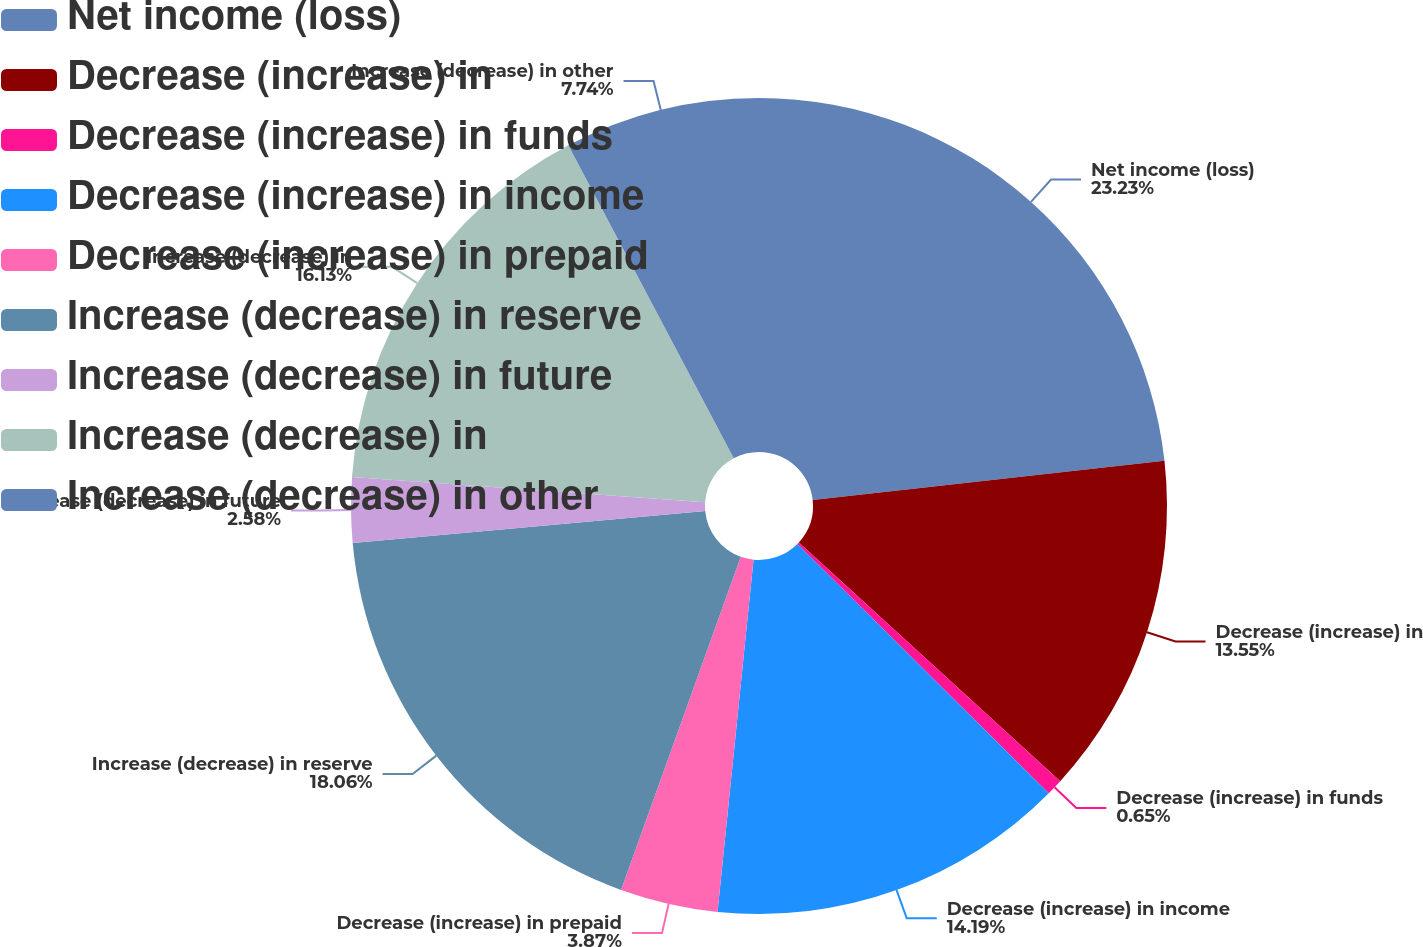<chart> <loc_0><loc_0><loc_500><loc_500><pie_chart><fcel>Net income (loss)<fcel>Decrease (increase) in<fcel>Decrease (increase) in funds<fcel>Decrease (increase) in income<fcel>Decrease (increase) in prepaid<fcel>Increase (decrease) in reserve<fcel>Increase (decrease) in future<fcel>Increase (decrease) in<fcel>Increase (decrease) in other<nl><fcel>23.23%<fcel>13.55%<fcel>0.65%<fcel>14.19%<fcel>3.87%<fcel>18.06%<fcel>2.58%<fcel>16.13%<fcel>7.74%<nl></chart> 